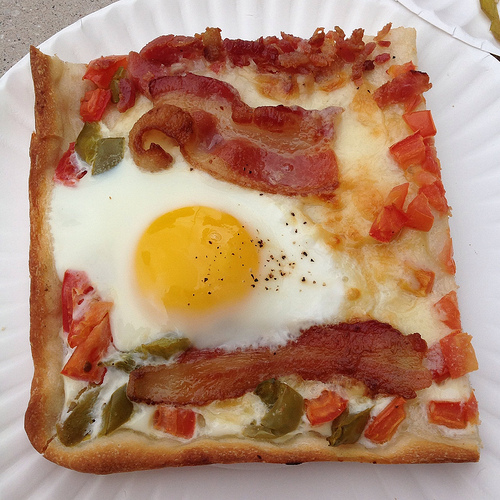Please provide the bounding box coordinate of the region this sentence describes: a gray table under the plate. The bounding box for the gray table under the plate is [0.0, 0.0, 0.23, 0.16], visually supporting the plate and subtly adding to the rustic aesthetic of the meal presentation. 